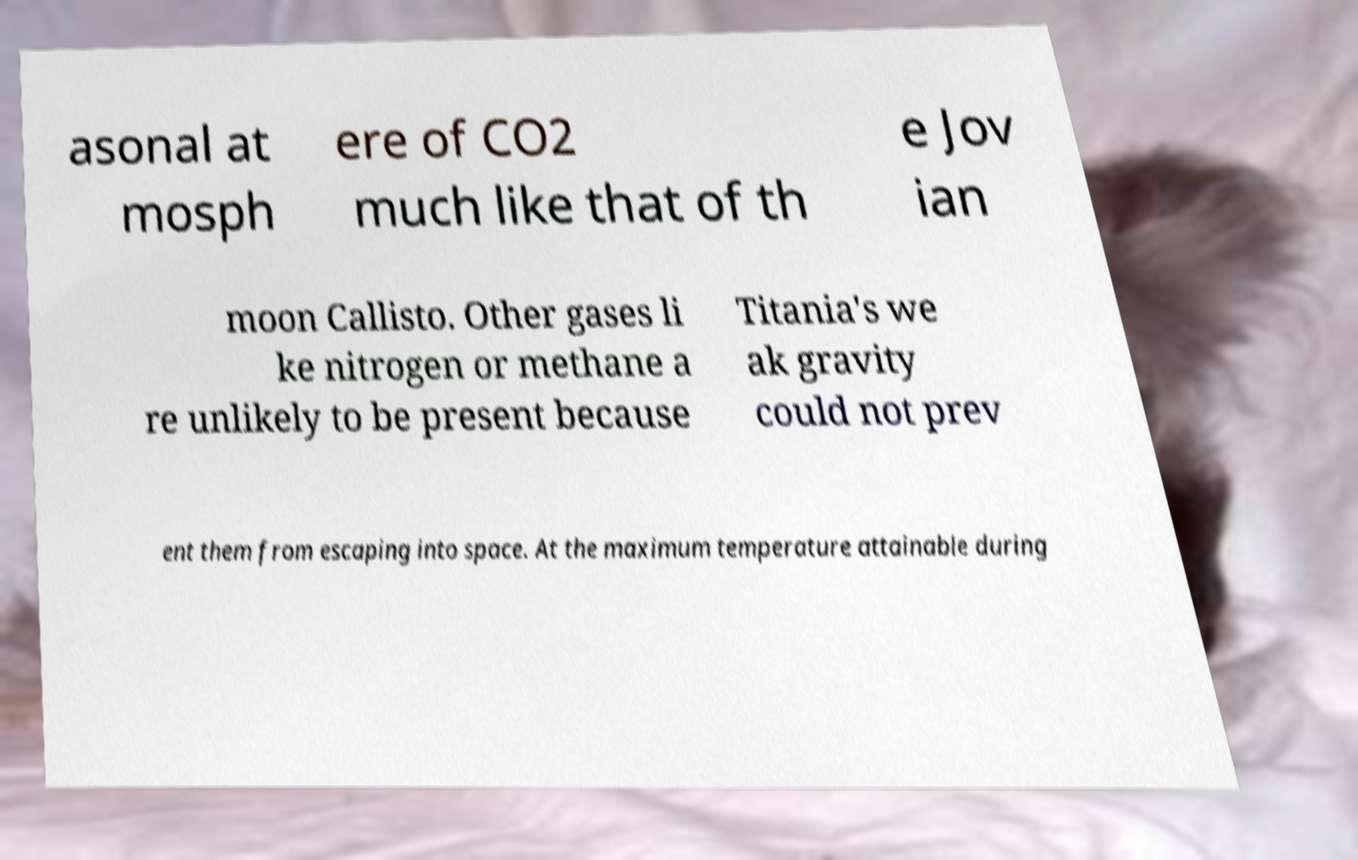Can you accurately transcribe the text from the provided image for me? asonal at mosph ere of CO2 much like that of th e Jov ian moon Callisto. Other gases li ke nitrogen or methane a re unlikely to be present because Titania's we ak gravity could not prev ent them from escaping into space. At the maximum temperature attainable during 